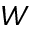<formula> <loc_0><loc_0><loc_500><loc_500>W</formula> 